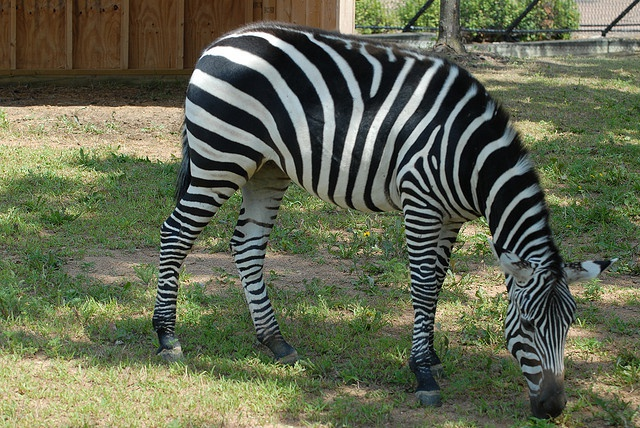Describe the objects in this image and their specific colors. I can see a zebra in maroon, black, darkgray, gray, and lightgray tones in this image. 